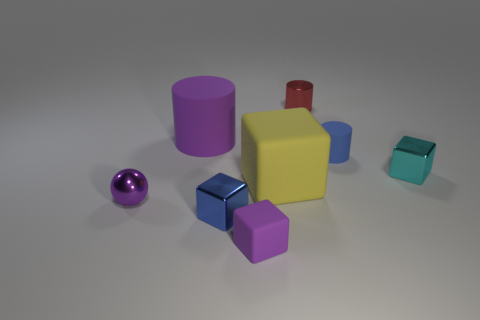There is a cylinder that is the same size as the yellow rubber thing; what is its color?
Your response must be concise. Purple. The purple rubber block has what size?
Keep it short and to the point. Small. Do the blue thing that is behind the tiny sphere and the purple cylinder have the same material?
Keep it short and to the point. Yes. Do the large purple rubber thing and the yellow rubber thing have the same shape?
Ensure brevity in your answer.  No. What shape is the big matte object right of the large object to the left of the small purple thing on the right side of the big purple rubber object?
Make the answer very short. Cube. Is the shape of the tiny blue object behind the small cyan shiny block the same as the big thing to the right of the large purple rubber thing?
Your answer should be very brief. No. Are there any large purple cylinders made of the same material as the purple block?
Provide a short and direct response. Yes. What is the color of the matte cylinder that is on the left side of the cylinder that is behind the purple rubber object behind the yellow object?
Your answer should be compact. Purple. Are the block left of the tiny purple block and the tiny purple object that is left of the tiny blue shiny object made of the same material?
Your answer should be very brief. Yes. What is the shape of the purple rubber thing in front of the yellow matte cube?
Your response must be concise. Cube. 